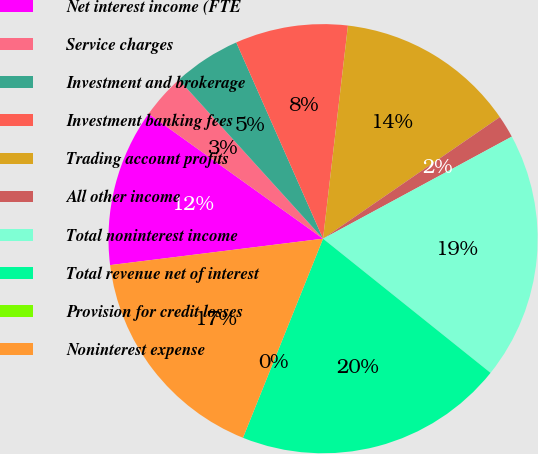Convert chart. <chart><loc_0><loc_0><loc_500><loc_500><pie_chart><fcel>Net interest income (FTE<fcel>Service charges<fcel>Investment and brokerage<fcel>Investment banking fees<fcel>Trading account profits<fcel>All other income<fcel>Total noninterest income<fcel>Total revenue net of interest<fcel>Provision for credit losses<fcel>Noninterest expense<nl><fcel>11.86%<fcel>3.39%<fcel>5.09%<fcel>8.48%<fcel>13.56%<fcel>1.7%<fcel>18.64%<fcel>20.34%<fcel>0.0%<fcel>16.95%<nl></chart> 